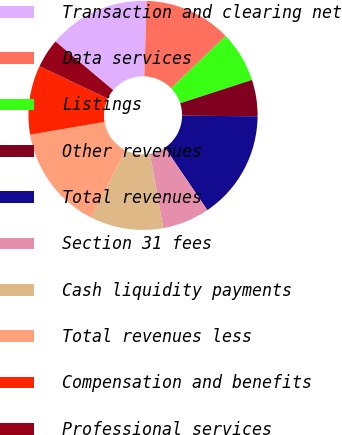Convert chart. <chart><loc_0><loc_0><loc_500><loc_500><pie_chart><fcel>Transaction and clearing net<fcel>Data services<fcel>Listings<fcel>Other revenues<fcel>Total revenues<fcel>Section 31 fees<fcel>Cash liquidity payments<fcel>Total revenues less<fcel>Compensation and benefits<fcel>Professional services<nl><fcel>14.36%<fcel>12.31%<fcel>7.18%<fcel>5.13%<fcel>15.38%<fcel>6.67%<fcel>10.26%<fcel>14.87%<fcel>9.74%<fcel>4.1%<nl></chart> 